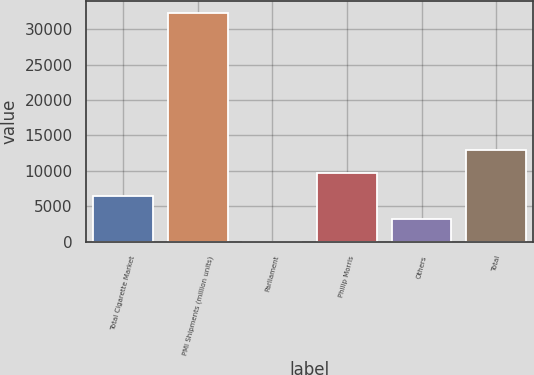Convert chart. <chart><loc_0><loc_0><loc_500><loc_500><bar_chart><fcel>Total Cigarette Market<fcel>PMI Shipments (million units)<fcel>Parliament<fcel>Philip Morris<fcel>Others<fcel>Total<nl><fcel>6466.36<fcel>32323<fcel>2.2<fcel>9698.44<fcel>3234.28<fcel>12930.5<nl></chart> 